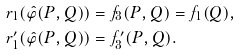Convert formula to latex. <formula><loc_0><loc_0><loc_500><loc_500>r _ { 1 } ( \hat { \varphi } ( P , Q ) ) & = f _ { 3 } ( P , Q ) = f _ { 1 } ( Q ) , \\ r _ { 1 } ^ { \prime } ( \hat { \varphi } ( P , Q ) ) & = f _ { 3 } ^ { \prime } ( P , Q ) .</formula> 